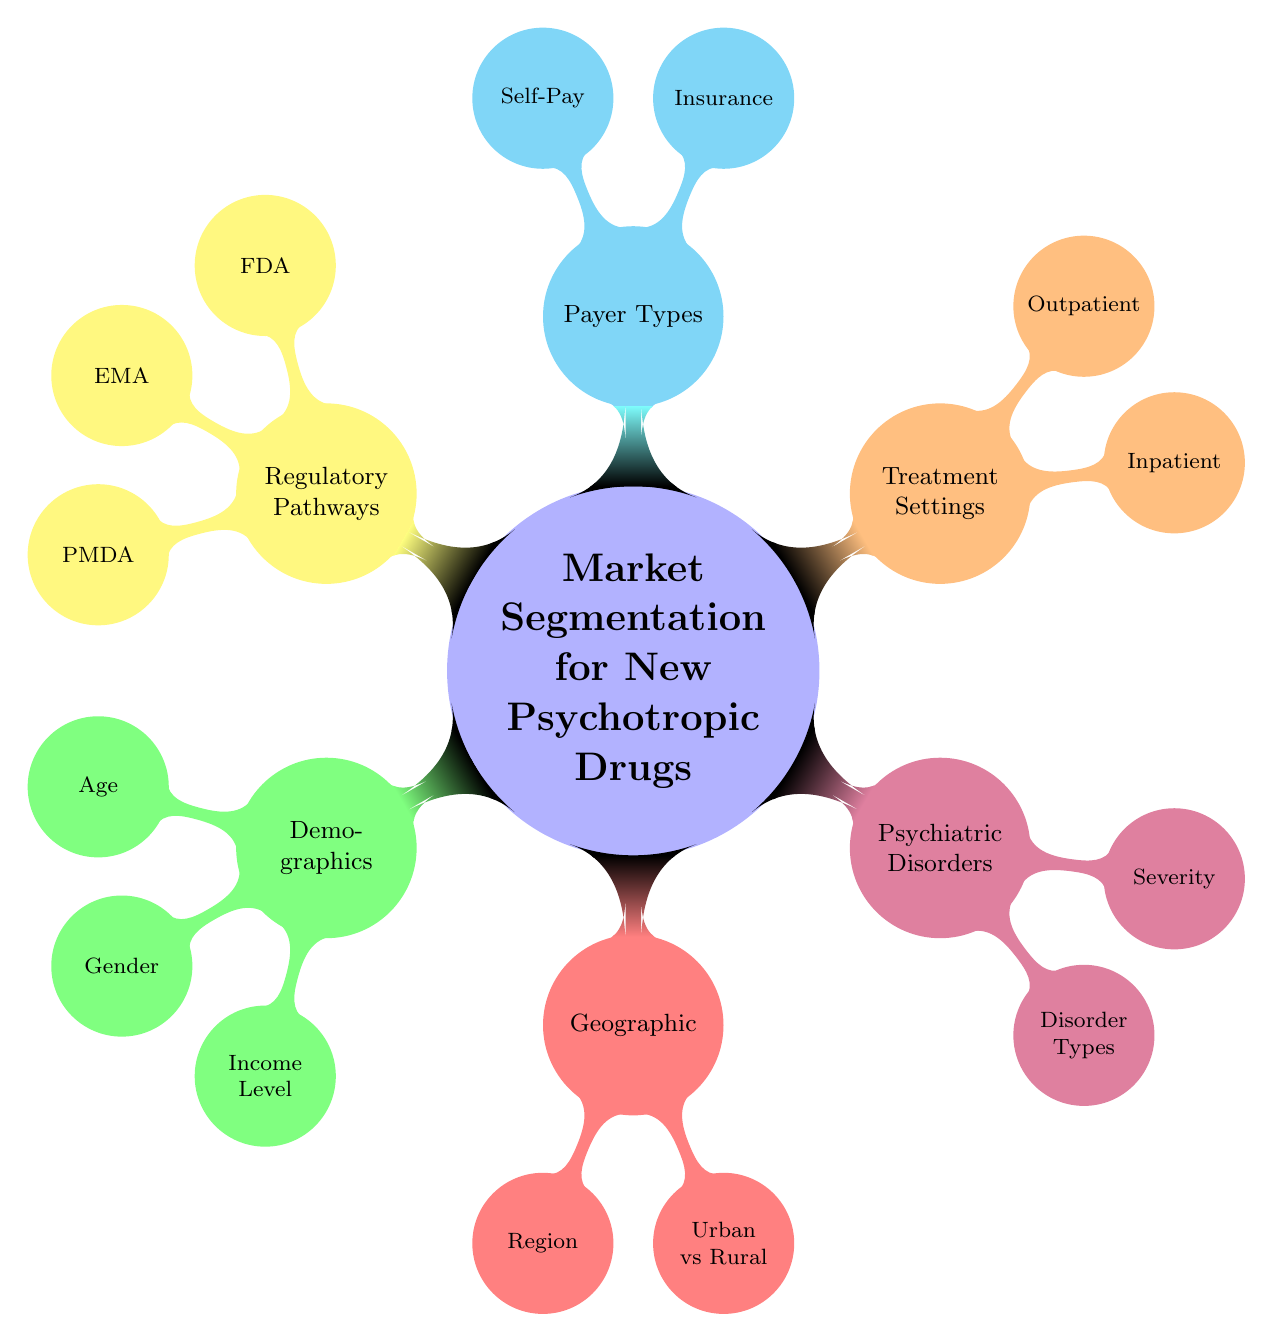What are the main categories of market segmentation? The diagram presents six main categories, each represented by a node. These categories are Demographics, Geographic, Psychiatric Disorders, Treatment Settings, Payer Types, and Regulatory Pathways.
Answer: Six What types of psychiatric disorders are listed? In the "Psychiatric Disorders" node, there are five types mentioned: Depression, Bipolar Disorder, Schizophrenia, Anxiety Disorders, and PTSD.
Answer: Five What are the payer types mentioned in the diagram? The "Payer Types" category contains two subcategories: Insurance and Self-Pay, indicating how patients might cover treatment costs.
Answer: Insurance and Self-Pay Which regulatory body has a section in the diagram related to approval processes? The "Regulatory Pathways" node includes three bodies: FDA, EMA, and PMDA. Each of these has an associated "Approval Process" mentioned, highlighting their roles in drug approvals.
Answer: FDA, EMA, PMDA How many demographic characteristics are identified? The "Demographics" node contains three characteristics: Age, Gender, and Income Level, showing that these factors can influence market segmentation strategies for psychotropic drugs.
Answer: Three What distinguishes urban from rural in the geographic segmentation? The "Geographic" node mentions two subcategories labeled Urban and Rural, indicating different settings that could significantly affect market strategies and needs.
Answer: Urban and Rural Which category includes inpatient treatment settings? The "Treatment Settings" node has two subcategories: Inpatient and Outpatient. The Inpatient category refers to treatment that occurs in facilities like Psychiatric Hospitals and General Hospitals, indicating a specific focus on controlled environments.
Answer: Inpatient How is severity of psychiatric disorders classified in the mind map? Within the "Psychiatric Disorders" section, severity is classified into three levels: Mild, Moderate, and Severe. These classifications help in understanding the variations in treatment needs for different patients.
Answer: Mild, Moderate, Severe What are the regions identified in the geographic segmentation? Under the "Geographic" category, five regions are specified: North America, Europe, Asia-Pacific, Latin America, and Middle East & Africa. This breakdown aids in analyzing market potential regionally.
Answer: North America, Europe, Asia-Pacific, Latin America, Middle East & Africa 